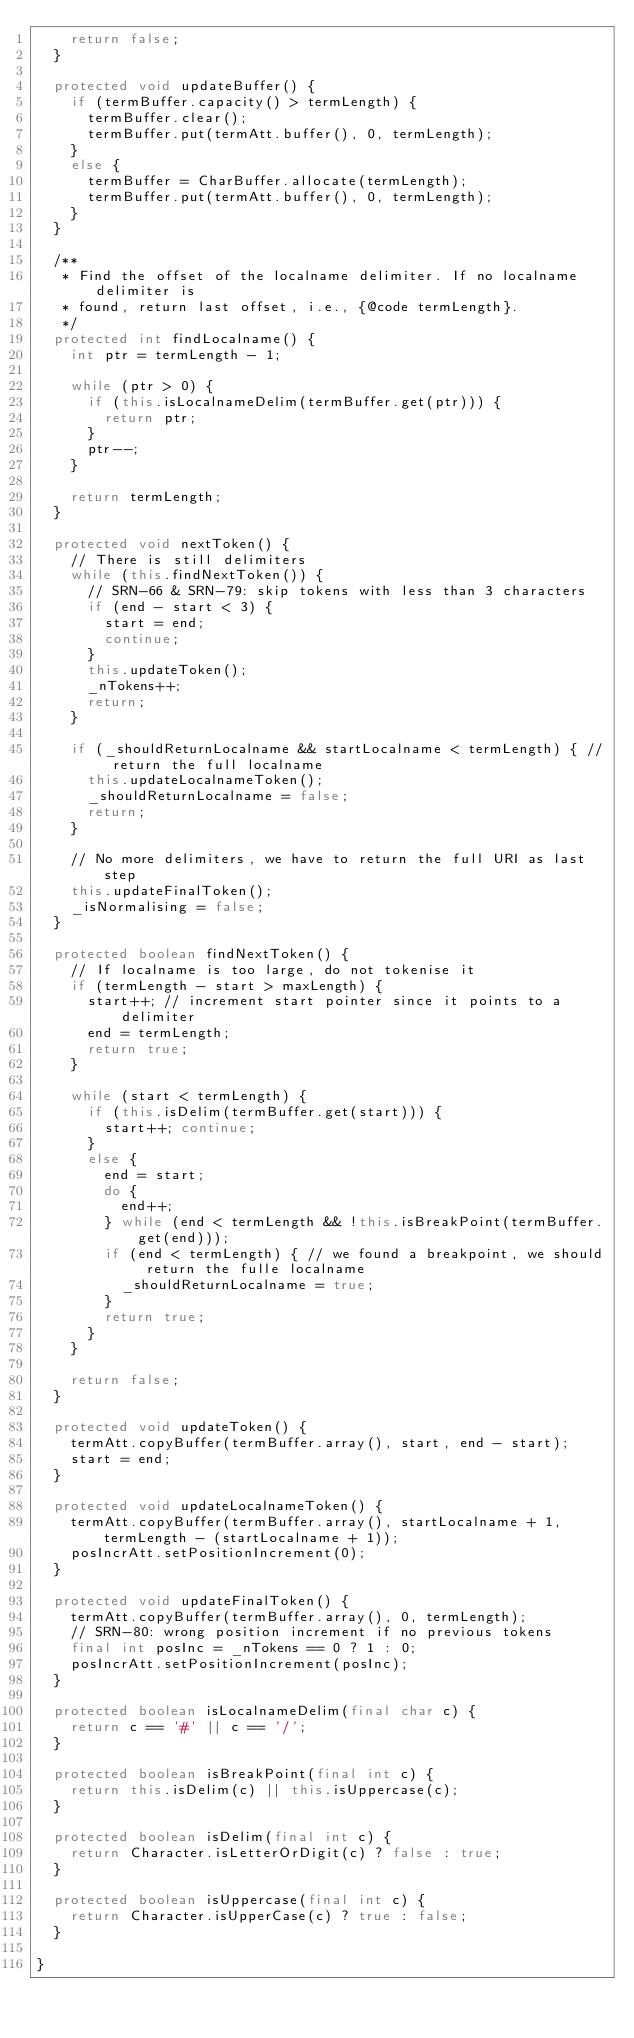<code> <loc_0><loc_0><loc_500><loc_500><_Java_>    return false;
  }

  protected void updateBuffer() {
    if (termBuffer.capacity() > termLength) {
      termBuffer.clear();
      termBuffer.put(termAtt.buffer(), 0, termLength);
    }
    else {
      termBuffer = CharBuffer.allocate(termLength);
      termBuffer.put(termAtt.buffer(), 0, termLength);
    }
  }

  /**
   * Find the offset of the localname delimiter. If no localname delimiter is
   * found, return last offset, i.e., {@code termLength}.
   */
  protected int findLocalname() {
    int ptr = termLength - 1;

    while (ptr > 0) {
      if (this.isLocalnameDelim(termBuffer.get(ptr))) {
        return ptr;
      }
      ptr--;
    }

    return termLength;
  }

  protected void nextToken() {
    // There is still delimiters
    while (this.findNextToken()) {
      // SRN-66 & SRN-79: skip tokens with less than 3 characters
      if (end - start < 3) {
        start = end;
        continue;
      }
      this.updateToken();
      _nTokens++;
      return;
    }

    if (_shouldReturnLocalname && startLocalname < termLength) { // return the full localname
      this.updateLocalnameToken();
      _shouldReturnLocalname = false;
      return;
    }

    // No more delimiters, we have to return the full URI as last step
    this.updateFinalToken();
    _isNormalising = false;
  }

  protected boolean findNextToken() {
    // If localname is too large, do not tokenise it
    if (termLength - start > maxLength) {
      start++; // increment start pointer since it points to a delimiter
      end = termLength;
      return true;
    }

    while (start < termLength) {
      if (this.isDelim(termBuffer.get(start))) {
        start++; continue;
      }
      else {
        end = start;
        do {
          end++;
        } while (end < termLength && !this.isBreakPoint(termBuffer.get(end)));
        if (end < termLength) { // we found a breakpoint, we should return the fulle localname
          _shouldReturnLocalname = true;
        }
        return true;
      }
    }

    return false;
  }

  protected void updateToken() {
    termAtt.copyBuffer(termBuffer.array(), start, end - start);
    start = end;
  }

  protected void updateLocalnameToken() {
    termAtt.copyBuffer(termBuffer.array(), startLocalname + 1, termLength - (startLocalname + 1));
    posIncrAtt.setPositionIncrement(0);
  }

  protected void updateFinalToken() {
    termAtt.copyBuffer(termBuffer.array(), 0, termLength);
    // SRN-80: wrong position increment if no previous tokens
    final int posInc = _nTokens == 0 ? 1 : 0;
    posIncrAtt.setPositionIncrement(posInc);
  }

  protected boolean isLocalnameDelim(final char c) {
    return c == '#' || c == '/';
  }

  protected boolean isBreakPoint(final int c) {
    return this.isDelim(c) || this.isUppercase(c);
  }

  protected boolean isDelim(final int c) {
    return Character.isLetterOrDigit(c) ? false : true;
  }

  protected boolean isUppercase(final int c) {
    return Character.isUpperCase(c) ? true : false;
  }

}
</code> 